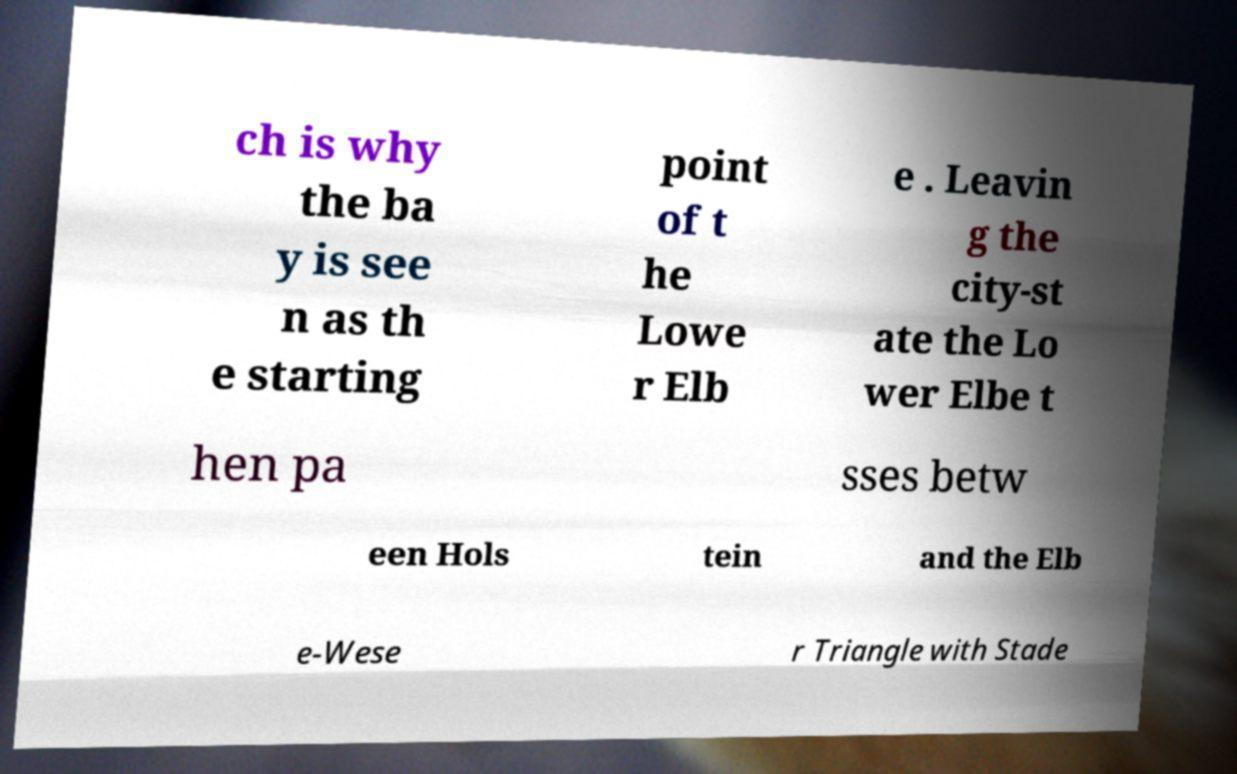Can you accurately transcribe the text from the provided image for me? ch is why the ba y is see n as th e starting point of t he Lowe r Elb e . Leavin g the city-st ate the Lo wer Elbe t hen pa sses betw een Hols tein and the Elb e-Wese r Triangle with Stade 